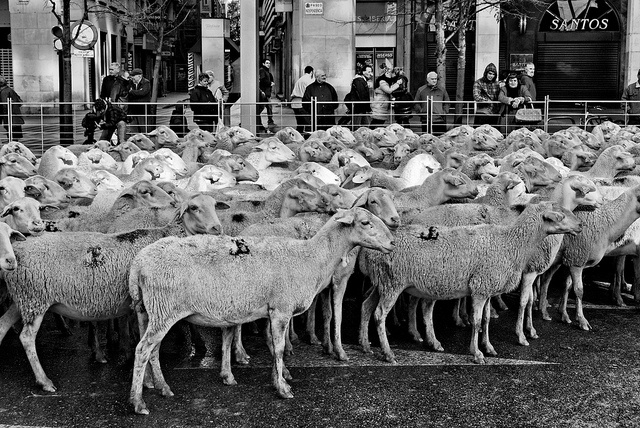Describe the objects in this image and their specific colors. I can see sheep in black, darkgray, gray, and lightgray tones, sheep in black, darkgray, gray, and lightgray tones, people in black, gray, darkgray, and lightgray tones, sheep in black, darkgray, gray, and lightgray tones, and sheep in black, darkgray, gray, and lightgray tones in this image. 